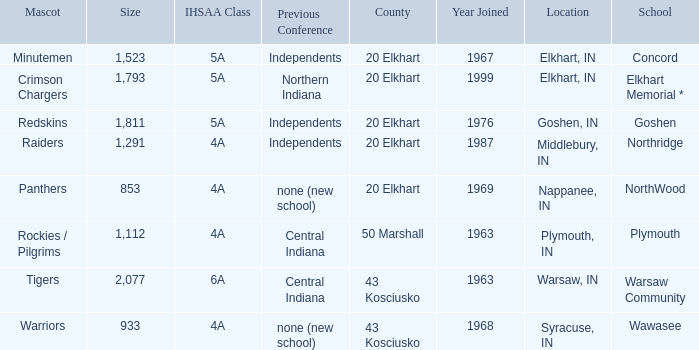What country joined before 1976, with IHSSA class of 5a, and a size larger than 1,112? 20 Elkhart. 